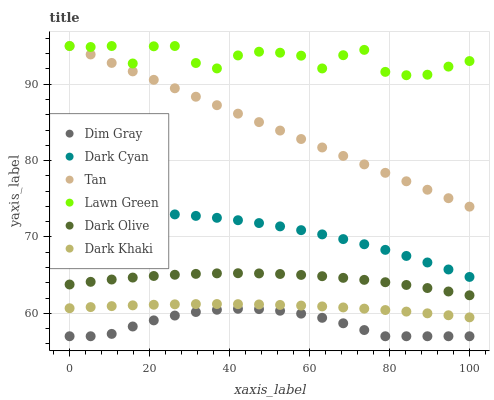Does Dim Gray have the minimum area under the curve?
Answer yes or no. Yes. Does Lawn Green have the maximum area under the curve?
Answer yes or no. Yes. Does Dark Olive have the minimum area under the curve?
Answer yes or no. No. Does Dark Olive have the maximum area under the curve?
Answer yes or no. No. Is Tan the smoothest?
Answer yes or no. Yes. Is Lawn Green the roughest?
Answer yes or no. Yes. Is Dim Gray the smoothest?
Answer yes or no. No. Is Dim Gray the roughest?
Answer yes or no. No. Does Dim Gray have the lowest value?
Answer yes or no. Yes. Does Dark Olive have the lowest value?
Answer yes or no. No. Does Tan have the highest value?
Answer yes or no. Yes. Does Dark Olive have the highest value?
Answer yes or no. No. Is Dark Khaki less than Lawn Green?
Answer yes or no. Yes. Is Tan greater than Dim Gray?
Answer yes or no. Yes. Does Lawn Green intersect Tan?
Answer yes or no. Yes. Is Lawn Green less than Tan?
Answer yes or no. No. Is Lawn Green greater than Tan?
Answer yes or no. No. Does Dark Khaki intersect Lawn Green?
Answer yes or no. No. 